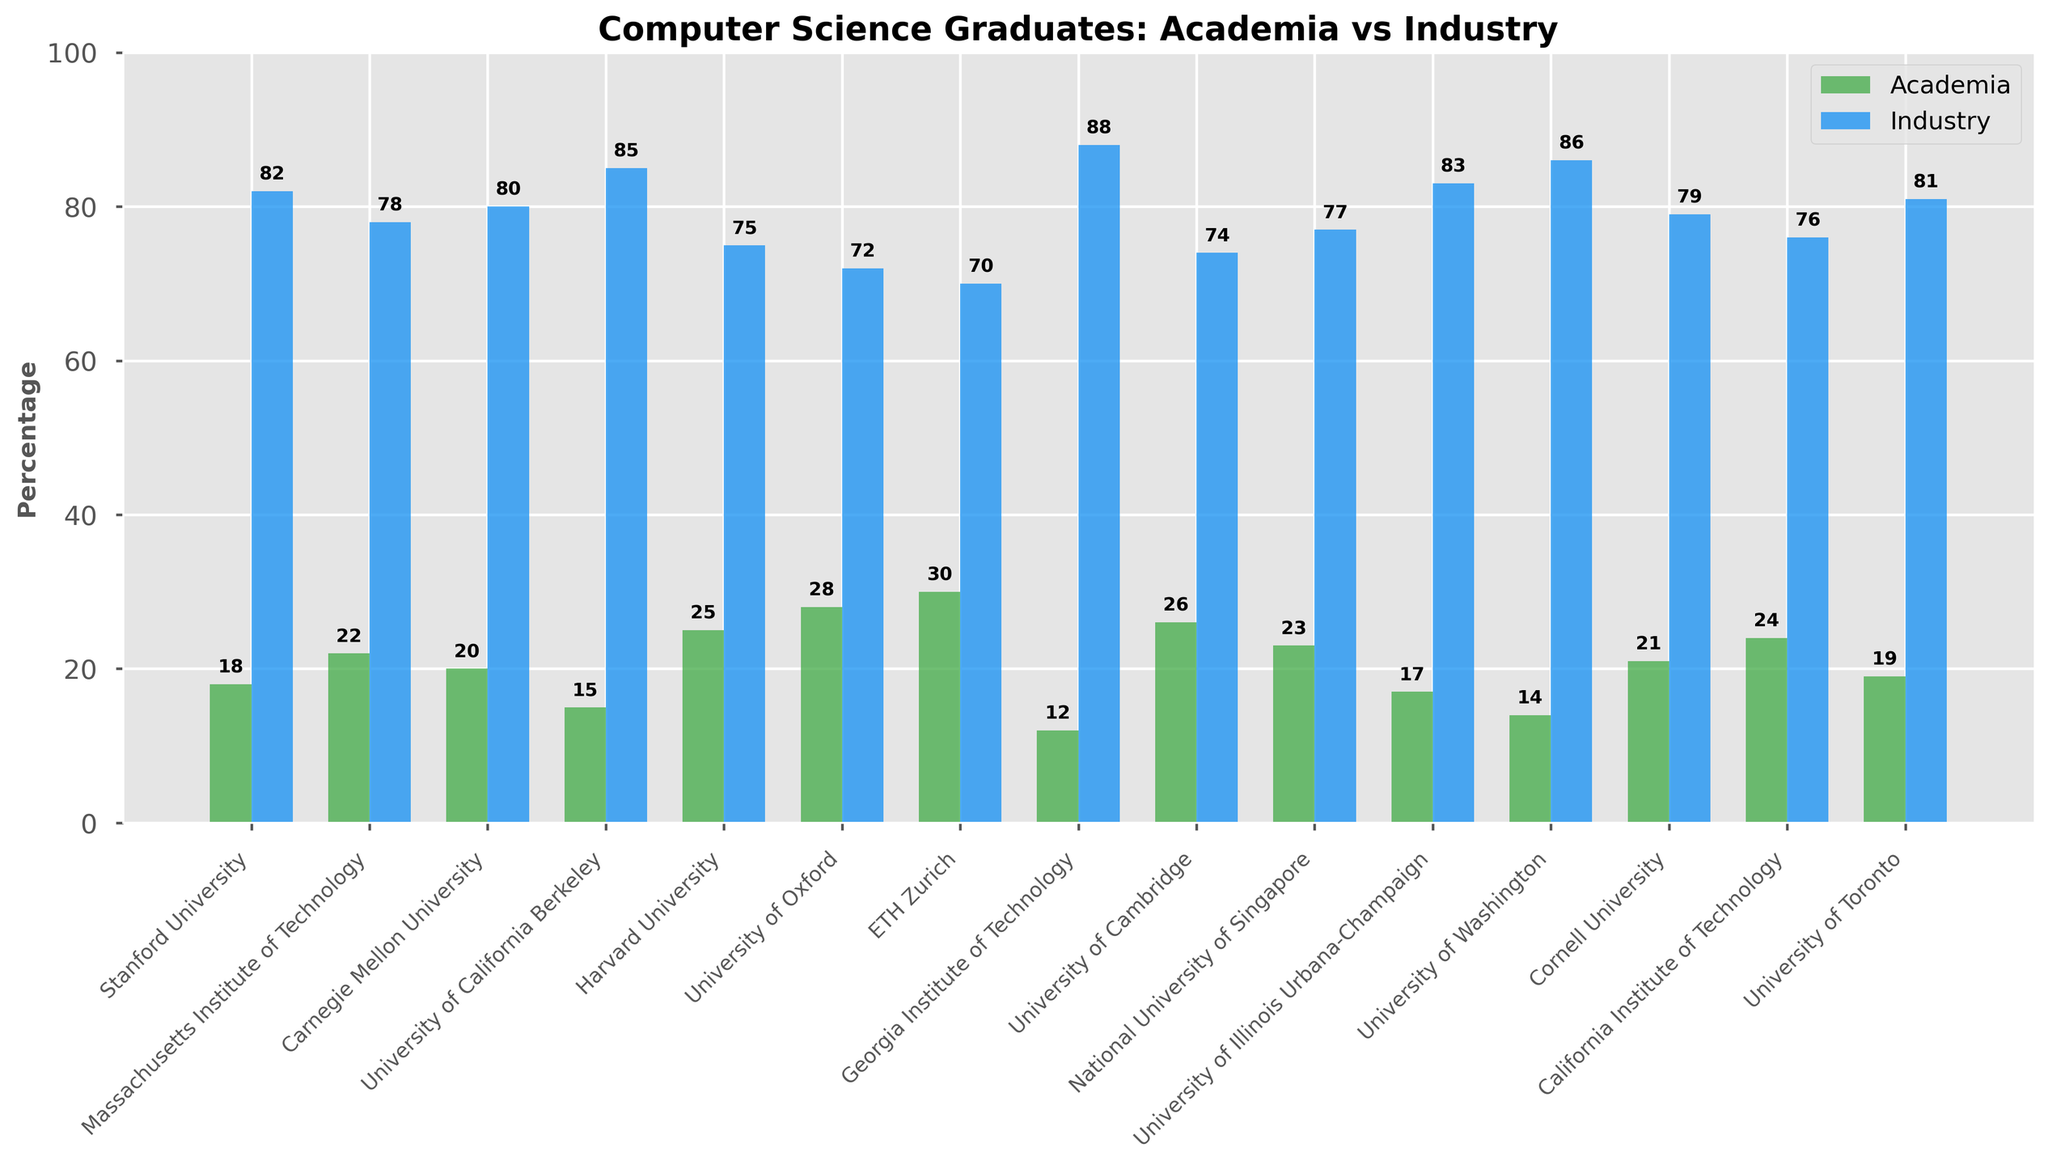Which university has the highest percentage of graduates pursuing a career in academia? Observe all the bars representing academia percentages across the universities. The highest bar corresponds to ETH Zurich, which is at 30%.
Answer: ETH Zurich How many universities have more than 80% of their graduates entering the industry? Examine the bars for industry percentages and count how many bars exceed 80%. The universities are Stanford, Georgia Tech, University of California Berkeley, and University of Illinois Urbana-Champaign. That's 4 universities.
Answer: 4 What is the difference in the percentage of graduates pursuing academia between Harvard University and Stanford University? Look at the academia bars for Harvard University and Stanford University. Harvard's percentage is 25%, and Stanford’s is 18%. Subtract 18 from 25.
Answer: 7% Which university has the smallest gap between academia and industry percentages? Calculate the differences between academia and industry percentages for each university. The smallest gap is at University of Cambridge with a gap of 48% (74% - 26%).
Answer: University of Cambridge Which two universities have the lowest percentage of graduates going into academia, and what are their percentages? Identify the smallest bars for academia. The two smallest percentages are for Georgia Tech (12%) and University of Washington (14%).
Answer: Georgia Tech (12%), University of Washington (14%) What is the average percentage of graduates pursuing a career in industry across all the universities listed? Add up all the industry percentages and divide by the number of universities (15). The sum is 82 + 78 + 80 + 85 + 75 + 72 + 70 + 88 + 74 + 77 + 83 + 86 + 79 + 76 + 81 = 1146. Then, 1146 / 15 = 76.4%.
Answer: 76.4% For which universities is the percentage of graduates going into industry less than 75%? Check the industry bars to see which ones are below 75%. They are University of Oxford (72%) and ETH Zurich (70%).
Answer: University of Oxford, ETH Zurich Which university has a higher percentage of graduates pursuing academia: University of Toronto or Cornell University? Compare the academia bars for University of Toronto (19%) and Cornell University (21%). Cornell has a higher percentage.
Answer: Cornell University What is the total percentage of graduates pursuing academia for Stanford, MIT, and UC Berkeley combined? Add the percentages for Stanford University (18%), MIT (22%), and UC Berkeley (15%). 18 + 22 + 15 = 55%.
Answer: 55% What is the median percentage of graduates going into academia across the listed universities? List all academia percentages in ascending order: [12, 14, 15, 17, 18, 19, 20, 21, 22, 23, 24, 25, 26, 28, 30]. The middle value, or median, when there are 15 data points is the 8th value, which is 21%.
Answer: 21% 